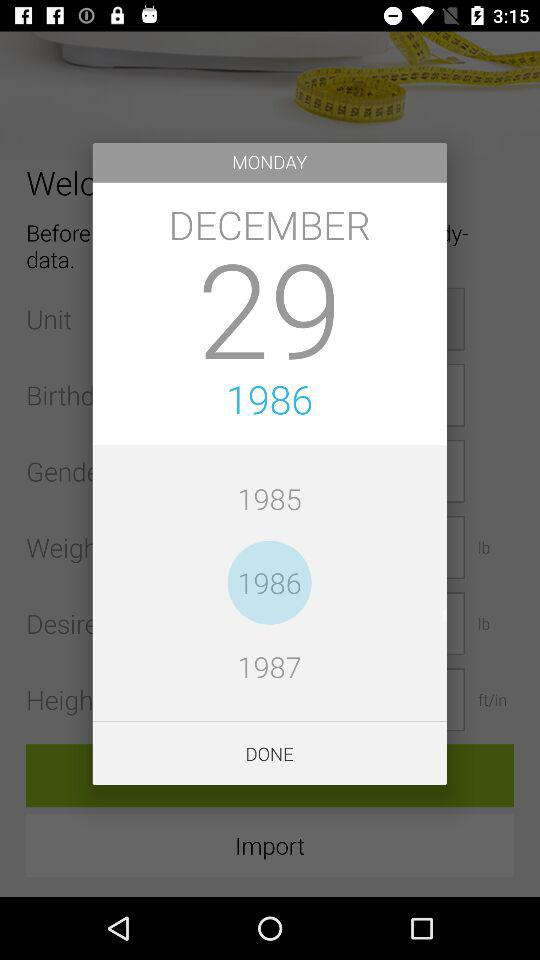What is the day on December 29, 1986? The day is Monday. 